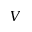Convert formula to latex. <formula><loc_0><loc_0><loc_500><loc_500>V</formula> 